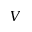Convert formula to latex. <formula><loc_0><loc_0><loc_500><loc_500>V</formula> 